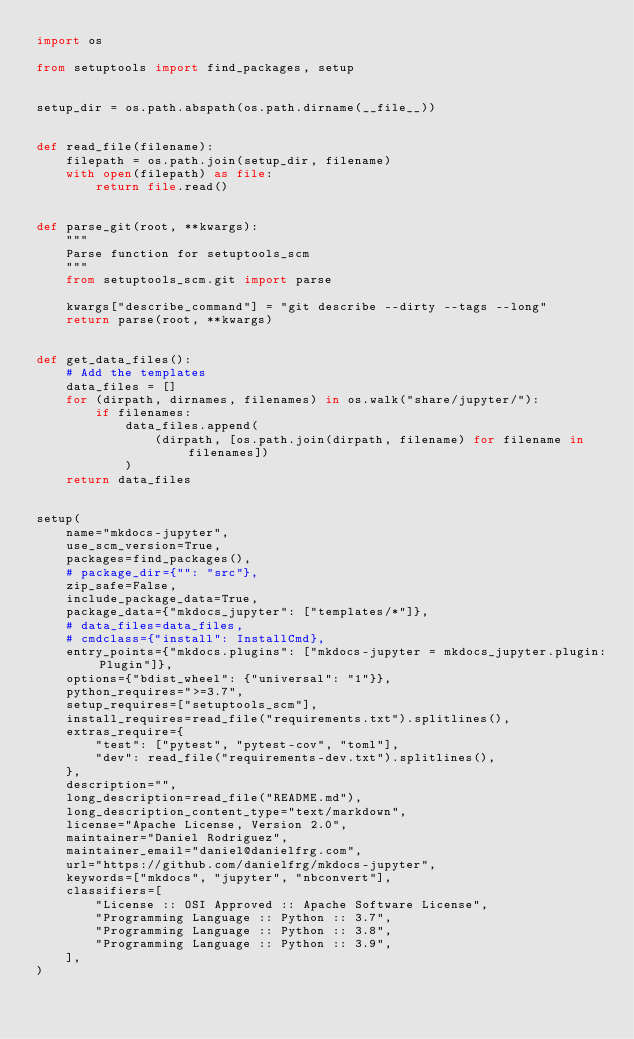Convert code to text. <code><loc_0><loc_0><loc_500><loc_500><_Python_>import os

from setuptools import find_packages, setup


setup_dir = os.path.abspath(os.path.dirname(__file__))


def read_file(filename):
    filepath = os.path.join(setup_dir, filename)
    with open(filepath) as file:
        return file.read()


def parse_git(root, **kwargs):
    """
    Parse function for setuptools_scm
    """
    from setuptools_scm.git import parse

    kwargs["describe_command"] = "git describe --dirty --tags --long"
    return parse(root, **kwargs)


def get_data_files():
    # Add the templates
    data_files = []
    for (dirpath, dirnames, filenames) in os.walk("share/jupyter/"):
        if filenames:
            data_files.append(
                (dirpath, [os.path.join(dirpath, filename) for filename in filenames])
            )
    return data_files


setup(
    name="mkdocs-jupyter",
    use_scm_version=True,
    packages=find_packages(),
    # package_dir={"": "src"},
    zip_safe=False,
    include_package_data=True,
    package_data={"mkdocs_jupyter": ["templates/*"]},
    # data_files=data_files,
    # cmdclass={"install": InstallCmd},
    entry_points={"mkdocs.plugins": ["mkdocs-jupyter = mkdocs_jupyter.plugin:Plugin"]},
    options={"bdist_wheel": {"universal": "1"}},
    python_requires=">=3.7",
    setup_requires=["setuptools_scm"],
    install_requires=read_file("requirements.txt").splitlines(),
    extras_require={
        "test": ["pytest", "pytest-cov", "toml"],
        "dev": read_file("requirements-dev.txt").splitlines(),
    },
    description="",
    long_description=read_file("README.md"),
    long_description_content_type="text/markdown",
    license="Apache License, Version 2.0",
    maintainer="Daniel Rodriguez",
    maintainer_email="daniel@danielfrg.com",
    url="https://github.com/danielfrg/mkdocs-jupyter",
    keywords=["mkdocs", "jupyter", "nbconvert"],
    classifiers=[
        "License :: OSI Approved :: Apache Software License",
        "Programming Language :: Python :: 3.7",
        "Programming Language :: Python :: 3.8",
        "Programming Language :: Python :: 3.9",
    ],
)
</code> 